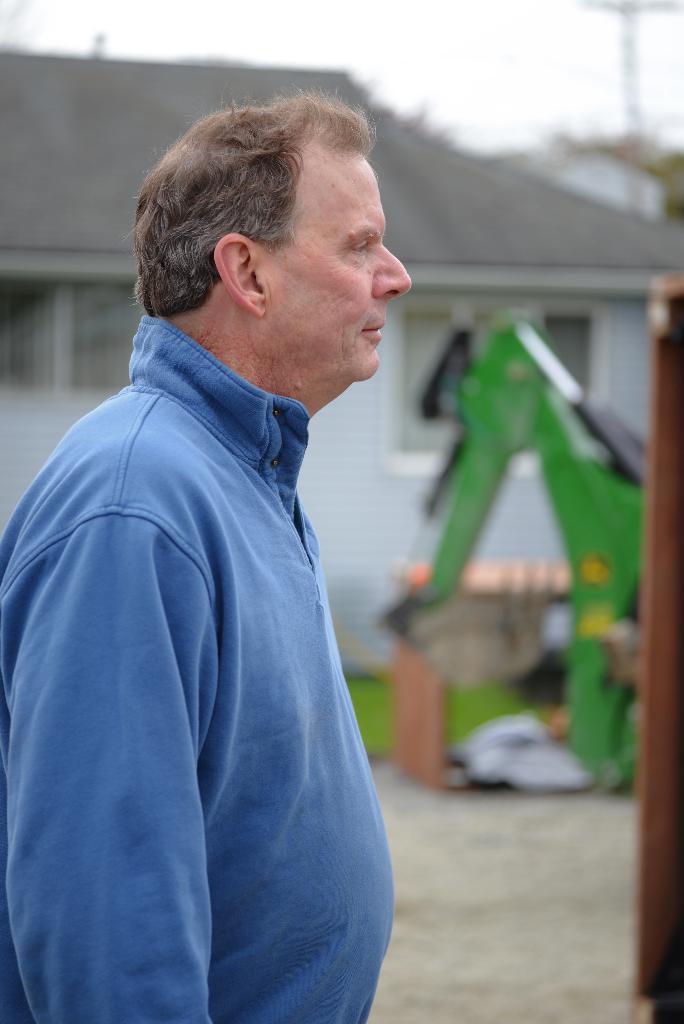In one or two sentences, can you explain what this image depicts? In this image we can see a person wearing blue shirt is standing. In the background, we can see a machine, a building with roof and the sky. 